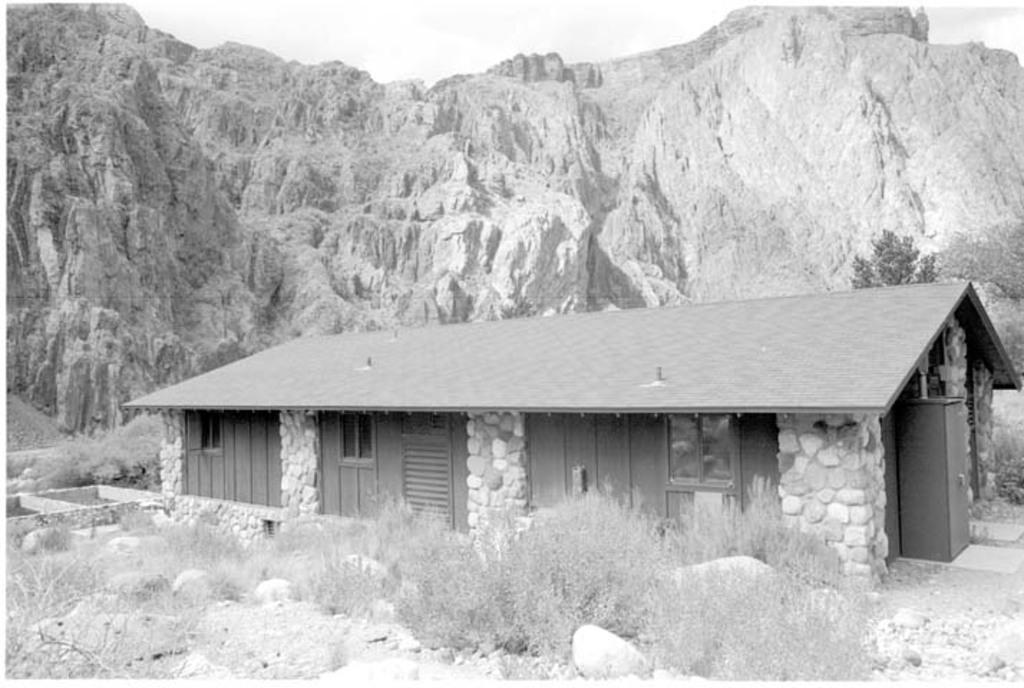What type of natural elements can be seen in the front of the image? There are stones in the front of the image. What type of vegetation is present in the image? There is grass in the image. What type of building is located in the center of the image? There is a cottage in the center of the image. What type of landscape feature is visible in the background of the image? There is a mountain in the background of the image. What direction is the cottage facing in the image? The direction the cottage is facing cannot be determined from the image. How many folds are there in the grass in the image? There are no folds in the grass in the image; it is a continuous, flat surface. 